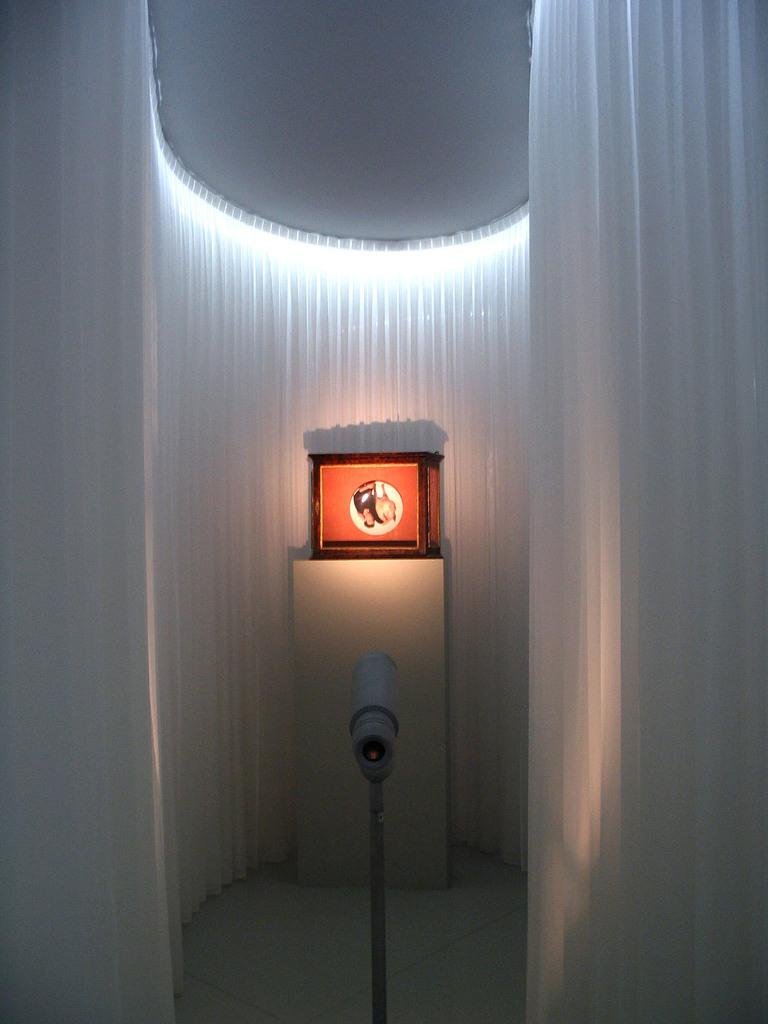What is located on the pedestal in the image? There is a box on a pedestal in the image. What can be seen illuminating the scene in the image? There are lights visible in the image. What type of window treatment is present in the image? There are curtains in the image. What type of pies are being served on the pedestal in the image? There are no pies present in the image; it features a box on a pedestal. Can you describe the squirrel's behavior near the pedestal in the image? There is no squirrel present in the image. 